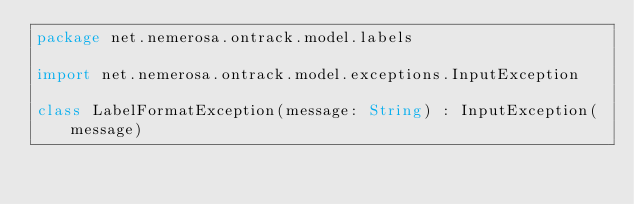Convert code to text. <code><loc_0><loc_0><loc_500><loc_500><_Kotlin_>package net.nemerosa.ontrack.model.labels

import net.nemerosa.ontrack.model.exceptions.InputException

class LabelFormatException(message: String) : InputException(message)
</code> 